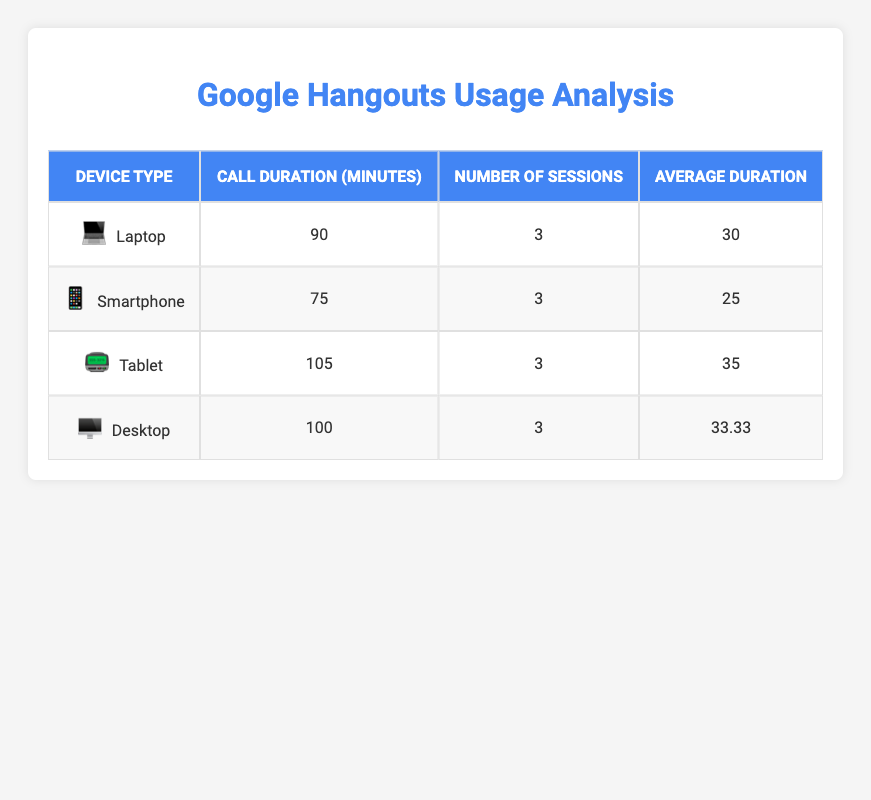What device type has the shortest average call duration? By comparing the average durations of all device types: Laptop (30 minutes), Smartphone (25 minutes), Tablet (35 minutes), and Desktop (33.33 minutes), we see that Smartphone has the lowest average duration.
Answer: Smartphone What is the total call duration for Tablet sessions? The total call duration for Tablets is given in the table, which shows it to be 105 minutes from the sum of its individual call durations: 20 + 35 + 50 = 105.
Answer: 105 minutes Is the average call duration for Desktop sessions higher than that for Smartphones? The average duration for Desktop is 33.33 minutes, while for Smartphones, it is 25 minutes. Since 33.33 is greater than 25, the statement is true.
Answer: Yes What is the difference in total call duration between Laptops and Desktops? The total call duration for Laptops is 90 minutes, and for Desktops, it is 100 minutes. The difference is calculated as 100 - 90 = 10 minutes.
Answer: 10 minutes Which device type had the highest number of sessions? From the table, all device types have 3 sessions each, so none stands out in terms of session count; they are all equal.
Answer: None, all have equal sessions What is the average call duration across all devices? To find the average, we need to sum up all the total durations (90 + 75 + 105 + 100) = 370 and divide by the number of sessions (4) giving us 370 / 12 = 30.83 minutes.
Answer: 30.83 minutes 